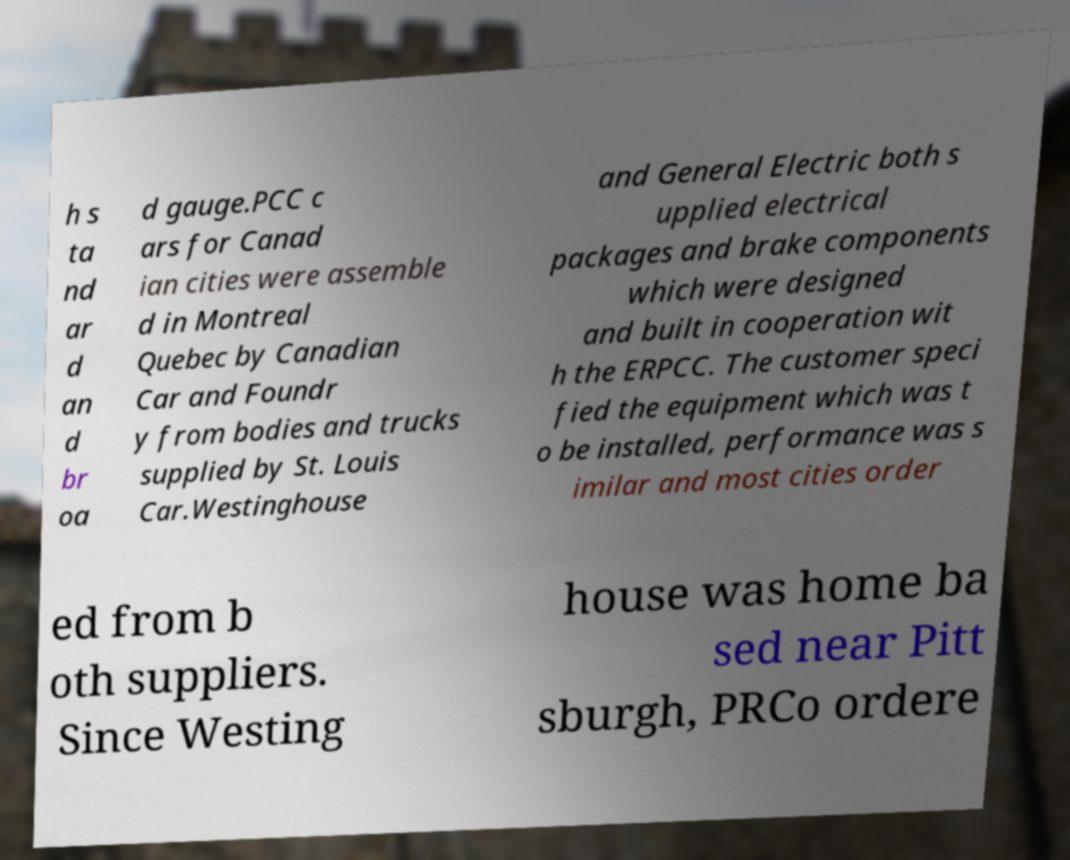For documentation purposes, I need the text within this image transcribed. Could you provide that? h s ta nd ar d an d br oa d gauge.PCC c ars for Canad ian cities were assemble d in Montreal Quebec by Canadian Car and Foundr y from bodies and trucks supplied by St. Louis Car.Westinghouse and General Electric both s upplied electrical packages and brake components which were designed and built in cooperation wit h the ERPCC. The customer speci fied the equipment which was t o be installed, performance was s imilar and most cities order ed from b oth suppliers. Since Westing house was home ba sed near Pitt sburgh, PRCo ordere 